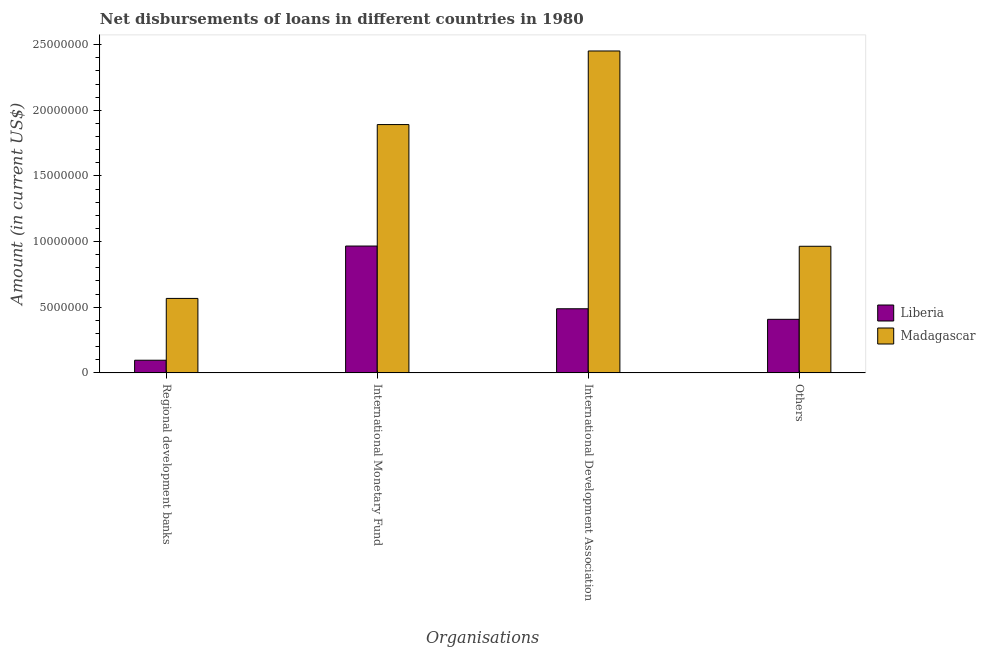Are the number of bars per tick equal to the number of legend labels?
Give a very brief answer. Yes. Are the number of bars on each tick of the X-axis equal?
Offer a very short reply. Yes. What is the label of the 4th group of bars from the left?
Your response must be concise. Others. What is the amount of loan disimbursed by international monetary fund in Liberia?
Offer a terse response. 9.66e+06. Across all countries, what is the maximum amount of loan disimbursed by regional development banks?
Your response must be concise. 5.67e+06. Across all countries, what is the minimum amount of loan disimbursed by other organisations?
Ensure brevity in your answer.  4.08e+06. In which country was the amount of loan disimbursed by regional development banks maximum?
Your answer should be compact. Madagascar. In which country was the amount of loan disimbursed by international development association minimum?
Your answer should be very brief. Liberia. What is the total amount of loan disimbursed by international monetary fund in the graph?
Provide a succinct answer. 2.86e+07. What is the difference between the amount of loan disimbursed by international development association in Madagascar and that in Liberia?
Your response must be concise. 1.96e+07. What is the difference between the amount of loan disimbursed by regional development banks in Madagascar and the amount of loan disimbursed by other organisations in Liberia?
Keep it short and to the point. 1.59e+06. What is the average amount of loan disimbursed by other organisations per country?
Offer a terse response. 6.86e+06. What is the difference between the amount of loan disimbursed by regional development banks and amount of loan disimbursed by international monetary fund in Madagascar?
Provide a succinct answer. -1.32e+07. What is the ratio of the amount of loan disimbursed by regional development banks in Madagascar to that in Liberia?
Provide a succinct answer. 5.89. Is the amount of loan disimbursed by international development association in Liberia less than that in Madagascar?
Offer a terse response. Yes. What is the difference between the highest and the second highest amount of loan disimbursed by other organisations?
Give a very brief answer. 5.56e+06. What is the difference between the highest and the lowest amount of loan disimbursed by international monetary fund?
Make the answer very short. 9.25e+06. Is the sum of the amount of loan disimbursed by regional development banks in Liberia and Madagascar greater than the maximum amount of loan disimbursed by international monetary fund across all countries?
Provide a short and direct response. No. What does the 2nd bar from the left in Others represents?
Keep it short and to the point. Madagascar. What does the 1st bar from the right in International Monetary Fund represents?
Your answer should be very brief. Madagascar. Is it the case that in every country, the sum of the amount of loan disimbursed by regional development banks and amount of loan disimbursed by international monetary fund is greater than the amount of loan disimbursed by international development association?
Your answer should be compact. Yes. How many bars are there?
Ensure brevity in your answer.  8. Does the graph contain grids?
Your response must be concise. No. How are the legend labels stacked?
Your response must be concise. Vertical. What is the title of the graph?
Give a very brief answer. Net disbursements of loans in different countries in 1980. Does "Timor-Leste" appear as one of the legend labels in the graph?
Your response must be concise. No. What is the label or title of the X-axis?
Provide a succinct answer. Organisations. What is the Amount (in current US$) in Liberia in Regional development banks?
Keep it short and to the point. 9.63e+05. What is the Amount (in current US$) of Madagascar in Regional development banks?
Your response must be concise. 5.67e+06. What is the Amount (in current US$) in Liberia in International Monetary Fund?
Offer a terse response. 9.66e+06. What is the Amount (in current US$) in Madagascar in International Monetary Fund?
Keep it short and to the point. 1.89e+07. What is the Amount (in current US$) of Liberia in International Development Association?
Keep it short and to the point. 4.88e+06. What is the Amount (in current US$) of Madagascar in International Development Association?
Your answer should be compact. 2.45e+07. What is the Amount (in current US$) of Liberia in Others?
Give a very brief answer. 4.08e+06. What is the Amount (in current US$) of Madagascar in Others?
Offer a very short reply. 9.64e+06. Across all Organisations, what is the maximum Amount (in current US$) in Liberia?
Offer a terse response. 9.66e+06. Across all Organisations, what is the maximum Amount (in current US$) of Madagascar?
Your answer should be compact. 2.45e+07. Across all Organisations, what is the minimum Amount (in current US$) in Liberia?
Give a very brief answer. 9.63e+05. Across all Organisations, what is the minimum Amount (in current US$) of Madagascar?
Make the answer very short. 5.67e+06. What is the total Amount (in current US$) in Liberia in the graph?
Keep it short and to the point. 1.96e+07. What is the total Amount (in current US$) of Madagascar in the graph?
Make the answer very short. 5.88e+07. What is the difference between the Amount (in current US$) of Liberia in Regional development banks and that in International Monetary Fund?
Your answer should be compact. -8.70e+06. What is the difference between the Amount (in current US$) in Madagascar in Regional development banks and that in International Monetary Fund?
Provide a succinct answer. -1.32e+07. What is the difference between the Amount (in current US$) of Liberia in Regional development banks and that in International Development Association?
Give a very brief answer. -3.92e+06. What is the difference between the Amount (in current US$) in Madagascar in Regional development banks and that in International Development Association?
Offer a terse response. -1.89e+07. What is the difference between the Amount (in current US$) in Liberia in Regional development banks and that in Others?
Ensure brevity in your answer.  -3.12e+06. What is the difference between the Amount (in current US$) in Madagascar in Regional development banks and that in Others?
Ensure brevity in your answer.  -3.97e+06. What is the difference between the Amount (in current US$) in Liberia in International Monetary Fund and that in International Development Association?
Give a very brief answer. 4.78e+06. What is the difference between the Amount (in current US$) in Madagascar in International Monetary Fund and that in International Development Association?
Offer a terse response. -5.61e+06. What is the difference between the Amount (in current US$) of Liberia in International Monetary Fund and that in Others?
Ensure brevity in your answer.  5.58e+06. What is the difference between the Amount (in current US$) in Madagascar in International Monetary Fund and that in Others?
Offer a terse response. 9.27e+06. What is the difference between the Amount (in current US$) of Liberia in International Development Association and that in Others?
Give a very brief answer. 8.04e+05. What is the difference between the Amount (in current US$) of Madagascar in International Development Association and that in Others?
Offer a very short reply. 1.49e+07. What is the difference between the Amount (in current US$) in Liberia in Regional development banks and the Amount (in current US$) in Madagascar in International Monetary Fund?
Offer a terse response. -1.80e+07. What is the difference between the Amount (in current US$) in Liberia in Regional development banks and the Amount (in current US$) in Madagascar in International Development Association?
Ensure brevity in your answer.  -2.36e+07. What is the difference between the Amount (in current US$) in Liberia in Regional development banks and the Amount (in current US$) in Madagascar in Others?
Your answer should be very brief. -8.68e+06. What is the difference between the Amount (in current US$) of Liberia in International Monetary Fund and the Amount (in current US$) of Madagascar in International Development Association?
Your response must be concise. -1.49e+07. What is the difference between the Amount (in current US$) in Liberia in International Monetary Fund and the Amount (in current US$) in Madagascar in Others?
Your answer should be very brief. 1.80e+04. What is the difference between the Amount (in current US$) in Liberia in International Development Association and the Amount (in current US$) in Madagascar in Others?
Give a very brief answer. -4.76e+06. What is the average Amount (in current US$) in Liberia per Organisations?
Provide a succinct answer. 4.90e+06. What is the average Amount (in current US$) of Madagascar per Organisations?
Provide a short and direct response. 1.47e+07. What is the difference between the Amount (in current US$) of Liberia and Amount (in current US$) of Madagascar in Regional development banks?
Give a very brief answer. -4.71e+06. What is the difference between the Amount (in current US$) in Liberia and Amount (in current US$) in Madagascar in International Monetary Fund?
Provide a short and direct response. -9.25e+06. What is the difference between the Amount (in current US$) in Liberia and Amount (in current US$) in Madagascar in International Development Association?
Your answer should be very brief. -1.96e+07. What is the difference between the Amount (in current US$) in Liberia and Amount (in current US$) in Madagascar in Others?
Your response must be concise. -5.56e+06. What is the ratio of the Amount (in current US$) of Liberia in Regional development banks to that in International Monetary Fund?
Ensure brevity in your answer.  0.1. What is the ratio of the Amount (in current US$) of Madagascar in Regional development banks to that in International Monetary Fund?
Ensure brevity in your answer.  0.3. What is the ratio of the Amount (in current US$) of Liberia in Regional development banks to that in International Development Association?
Your answer should be very brief. 0.2. What is the ratio of the Amount (in current US$) of Madagascar in Regional development banks to that in International Development Association?
Offer a very short reply. 0.23. What is the ratio of the Amount (in current US$) of Liberia in Regional development banks to that in Others?
Ensure brevity in your answer.  0.24. What is the ratio of the Amount (in current US$) of Madagascar in Regional development banks to that in Others?
Your answer should be very brief. 0.59. What is the ratio of the Amount (in current US$) of Liberia in International Monetary Fund to that in International Development Association?
Your answer should be compact. 1.98. What is the ratio of the Amount (in current US$) in Madagascar in International Monetary Fund to that in International Development Association?
Keep it short and to the point. 0.77. What is the ratio of the Amount (in current US$) in Liberia in International Monetary Fund to that in Others?
Your answer should be compact. 2.37. What is the ratio of the Amount (in current US$) of Madagascar in International Monetary Fund to that in Others?
Provide a short and direct response. 1.96. What is the ratio of the Amount (in current US$) of Liberia in International Development Association to that in Others?
Provide a short and direct response. 1.2. What is the ratio of the Amount (in current US$) in Madagascar in International Development Association to that in Others?
Offer a very short reply. 2.54. What is the difference between the highest and the second highest Amount (in current US$) in Liberia?
Ensure brevity in your answer.  4.78e+06. What is the difference between the highest and the second highest Amount (in current US$) of Madagascar?
Provide a succinct answer. 5.61e+06. What is the difference between the highest and the lowest Amount (in current US$) of Liberia?
Offer a very short reply. 8.70e+06. What is the difference between the highest and the lowest Amount (in current US$) in Madagascar?
Provide a succinct answer. 1.89e+07. 